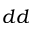<formula> <loc_0><loc_0><loc_500><loc_500>d d</formula> 